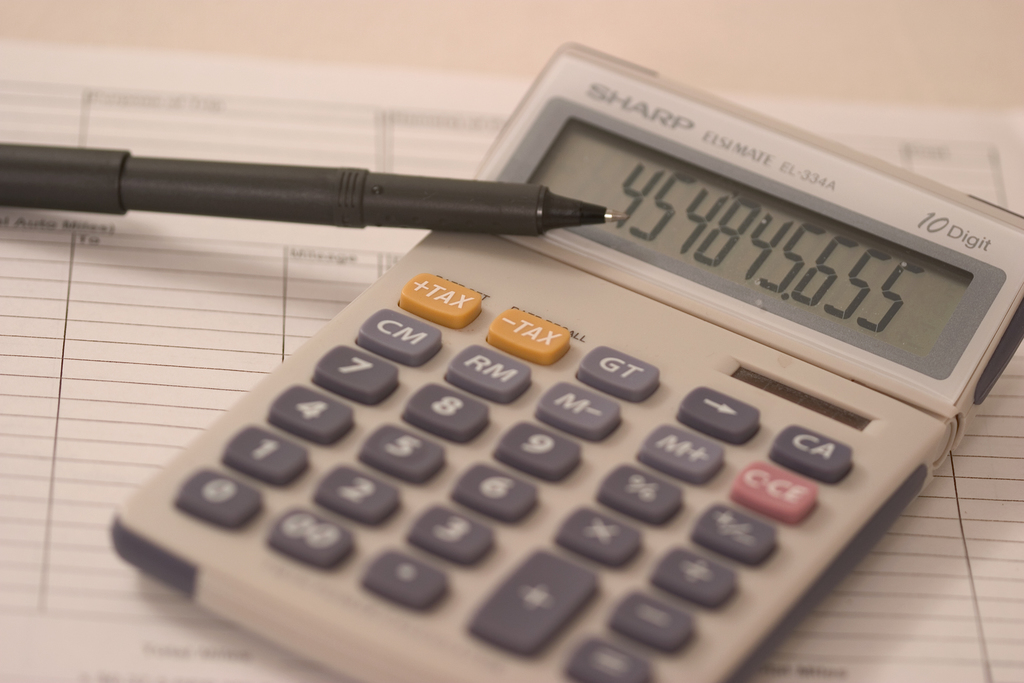Can you elaborate on the elements of the picture provided? The image prominently features a Sharp EL-334A calculator, a model renowned for its clear 10-digit display. The calculator shows a number, 4548655, which might be indicative of a specific financial calculation, possibly related to tax as suggested by the 'TAX' button that is highlighted. A black, possibly ballpoint pen, rests atop the calculator, pointing towards the role of manual note-making or verification in conjunction with digital calculations. The backdrop is a sheet filled with lined numerical entries, typical of financial documents or balance sheets. The entire setup appears to be a typical scene from an accounting or business environment where precision and accuracy in numerical data are paramount. This suggests that detailed financial analysis or tax calculation might be underway. 